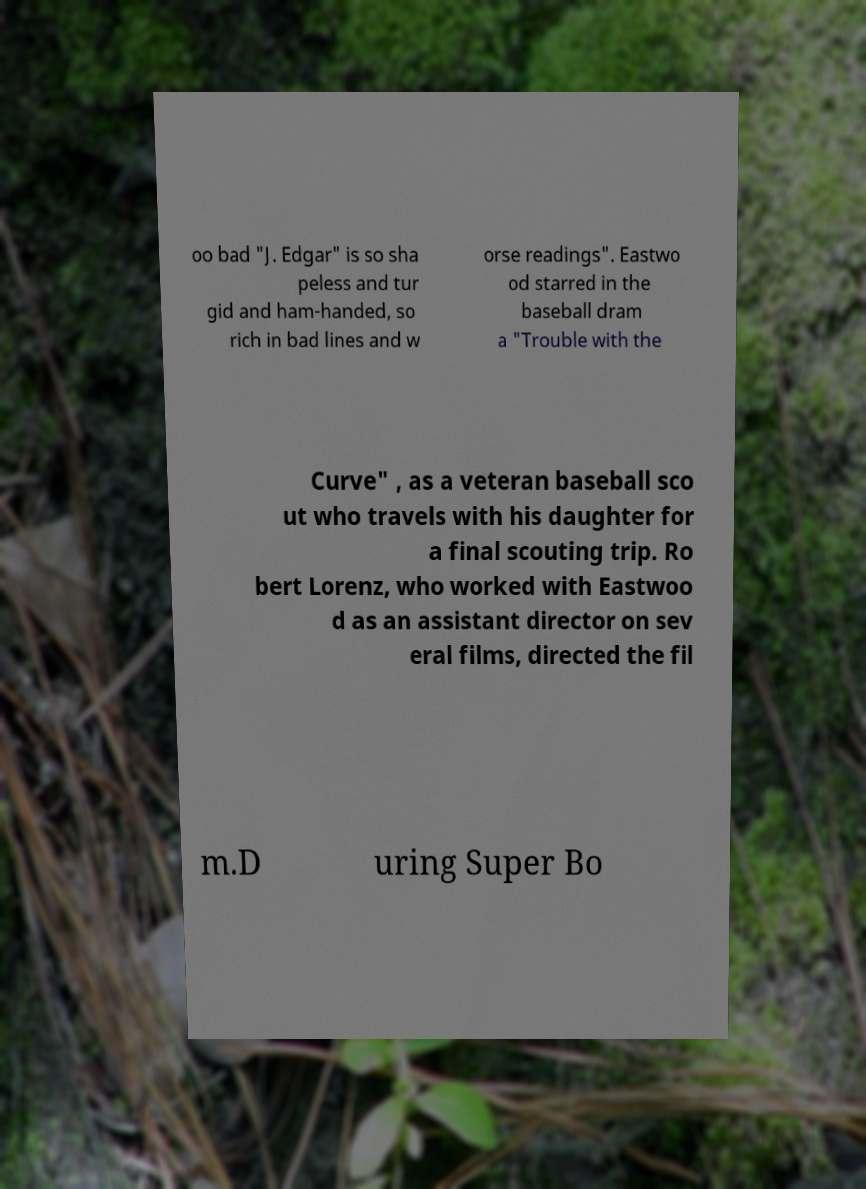Can you accurately transcribe the text from the provided image for me? oo bad "J. Edgar" is so sha peless and tur gid and ham-handed, so rich in bad lines and w orse readings". Eastwo od starred in the baseball dram a "Trouble with the Curve" , as a veteran baseball sco ut who travels with his daughter for a final scouting trip. Ro bert Lorenz, who worked with Eastwoo d as an assistant director on sev eral films, directed the fil m.D uring Super Bo 